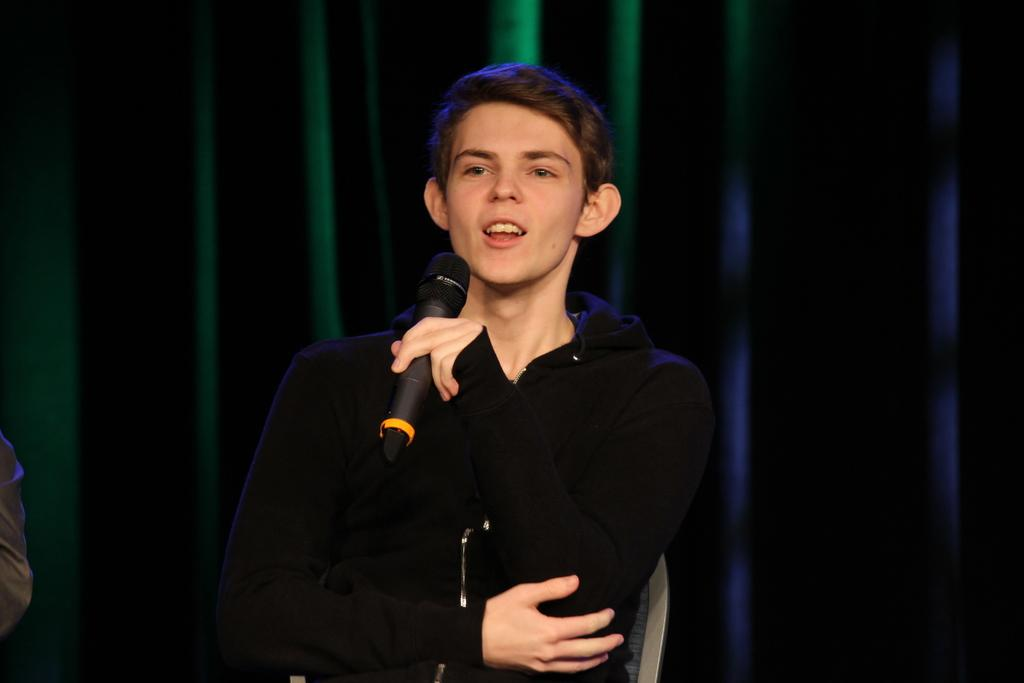What is the main subject of the image? There is a person sitting in the center of the image. What is the person holding in his hand? The person is holding a mic in his hand. What can be seen in the background of the image? There is a curtain in the background of the image. What invention is the person demonstrating in the image? There is no invention being demonstrated in the image; the person is simply holding a mic. What type of trip is the person taking in the image? There is no trip depicted in the image; the person is sitting in a stationary position. 